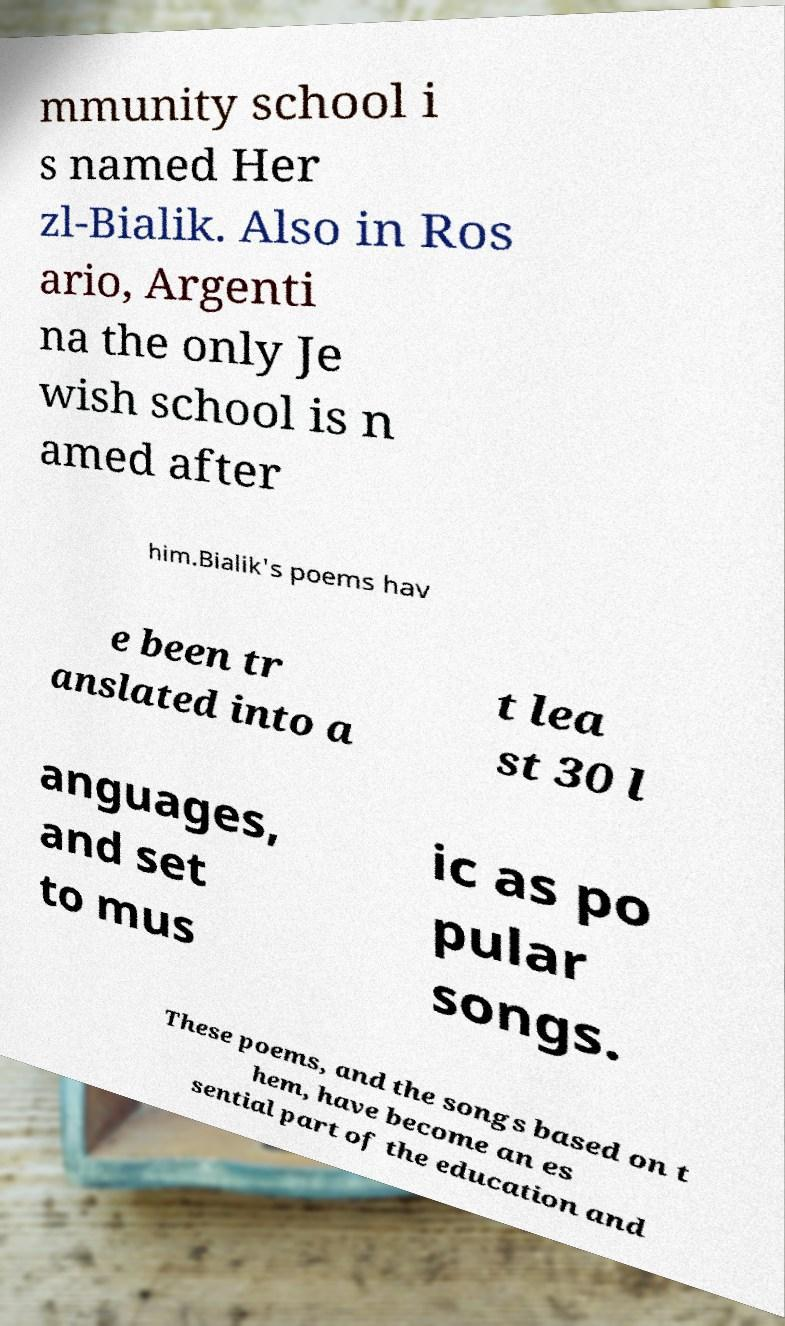Could you extract and type out the text from this image? mmunity school i s named Her zl-Bialik. Also in Ros ario, Argenti na the only Je wish school is n amed after him.Bialik's poems hav e been tr anslated into a t lea st 30 l anguages, and set to mus ic as po pular songs. These poems, and the songs based on t hem, have become an es sential part of the education and 